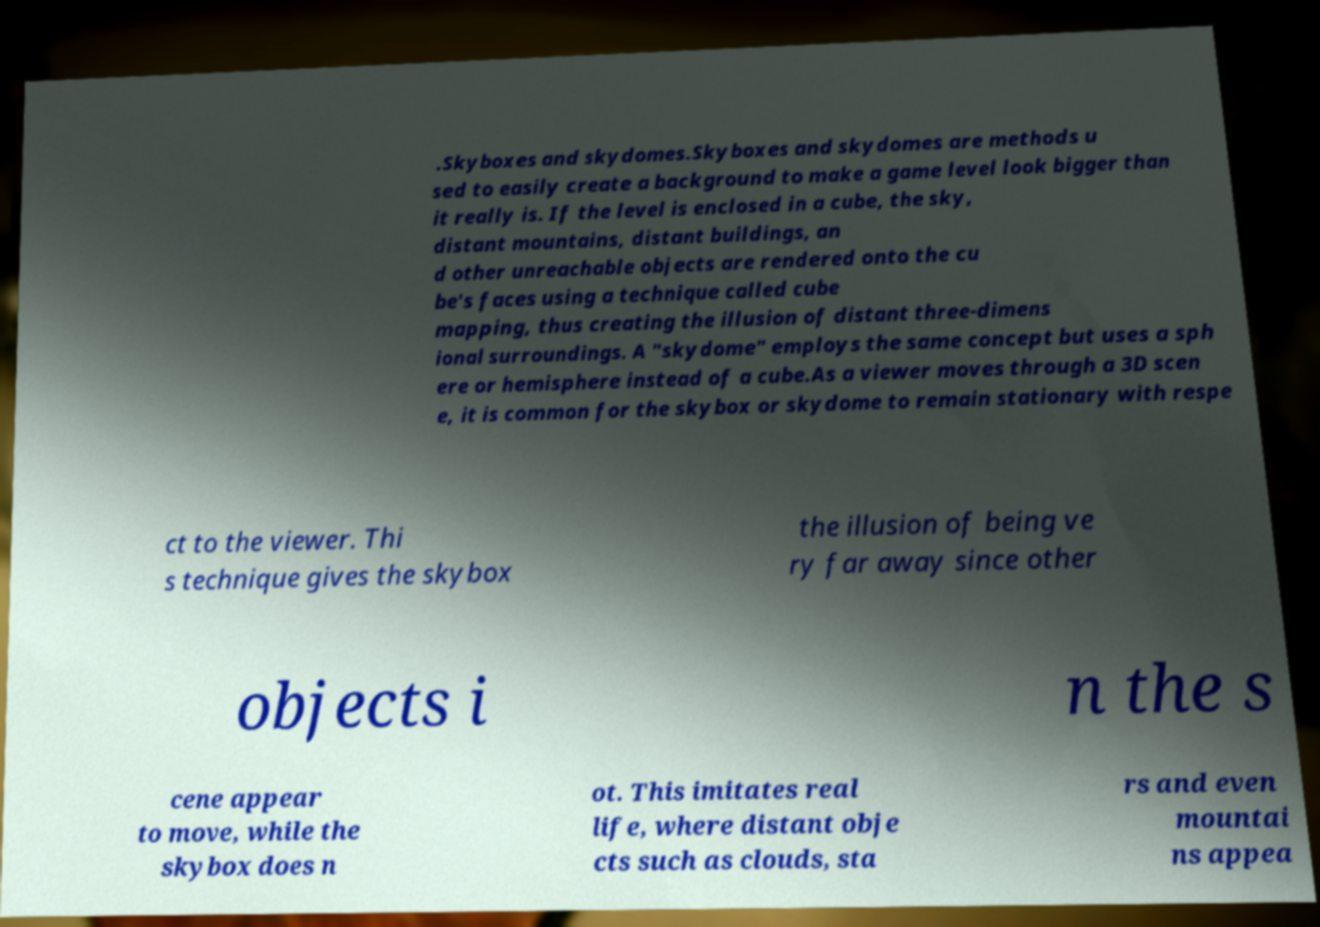Could you extract and type out the text from this image? .Skyboxes and skydomes.Skyboxes and skydomes are methods u sed to easily create a background to make a game level look bigger than it really is. If the level is enclosed in a cube, the sky, distant mountains, distant buildings, an d other unreachable objects are rendered onto the cu be's faces using a technique called cube mapping, thus creating the illusion of distant three-dimens ional surroundings. A "skydome" employs the same concept but uses a sph ere or hemisphere instead of a cube.As a viewer moves through a 3D scen e, it is common for the skybox or skydome to remain stationary with respe ct to the viewer. Thi s technique gives the skybox the illusion of being ve ry far away since other objects i n the s cene appear to move, while the skybox does n ot. This imitates real life, where distant obje cts such as clouds, sta rs and even mountai ns appea 